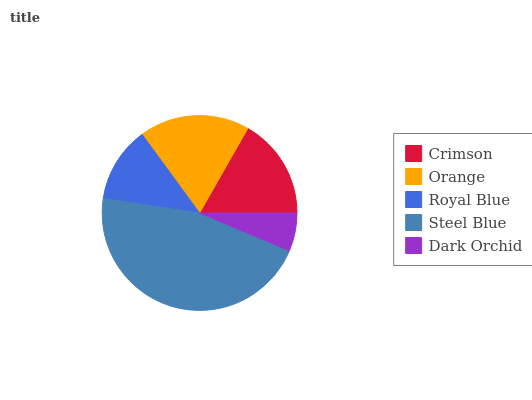Is Dark Orchid the minimum?
Answer yes or no. Yes. Is Steel Blue the maximum?
Answer yes or no. Yes. Is Orange the minimum?
Answer yes or no. No. Is Orange the maximum?
Answer yes or no. No. Is Orange greater than Crimson?
Answer yes or no. Yes. Is Crimson less than Orange?
Answer yes or no. Yes. Is Crimson greater than Orange?
Answer yes or no. No. Is Orange less than Crimson?
Answer yes or no. No. Is Crimson the high median?
Answer yes or no. Yes. Is Crimson the low median?
Answer yes or no. Yes. Is Steel Blue the high median?
Answer yes or no. No. Is Steel Blue the low median?
Answer yes or no. No. 